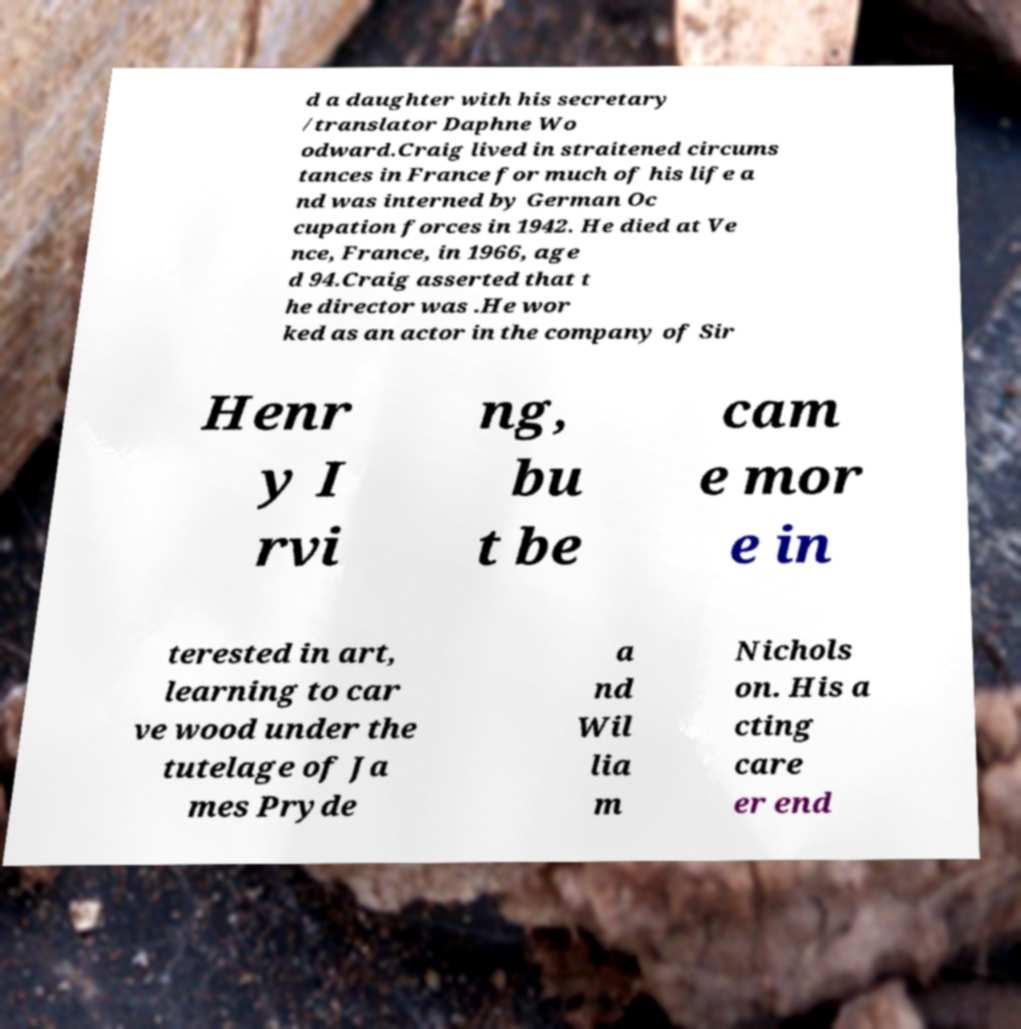Can you read and provide the text displayed in the image?This photo seems to have some interesting text. Can you extract and type it out for me? d a daughter with his secretary /translator Daphne Wo odward.Craig lived in straitened circums tances in France for much of his life a nd was interned by German Oc cupation forces in 1942. He died at Ve nce, France, in 1966, age d 94.Craig asserted that t he director was .He wor ked as an actor in the company of Sir Henr y I rvi ng, bu t be cam e mor e in terested in art, learning to car ve wood under the tutelage of Ja mes Pryde a nd Wil lia m Nichols on. His a cting care er end 